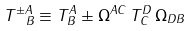<formula> <loc_0><loc_0><loc_500><loc_500>T ^ { \pm A } _ { \ \, B } \equiv T ^ { A } _ { B } \pm \Omega ^ { A C } \, T ^ { D } _ { C } \, \Omega _ { D B }</formula> 